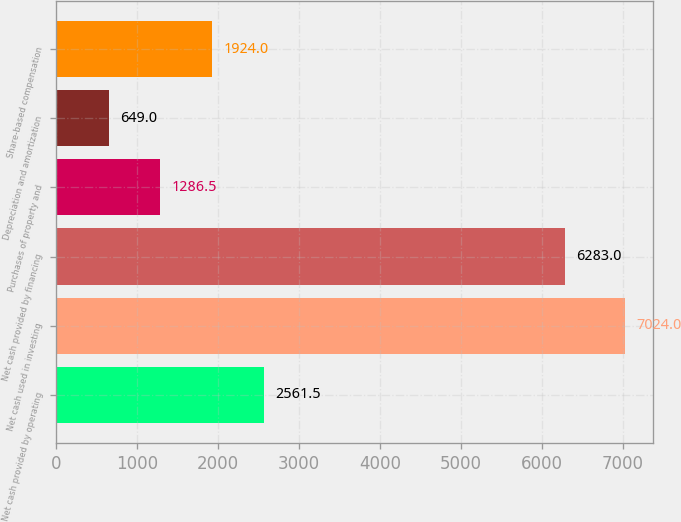<chart> <loc_0><loc_0><loc_500><loc_500><bar_chart><fcel>Net cash provided by operating<fcel>Net cash used in investing<fcel>Net cash provided by financing<fcel>Purchases of property and<fcel>Depreciation and amortization<fcel>Share-based compensation<nl><fcel>2561.5<fcel>7024<fcel>6283<fcel>1286.5<fcel>649<fcel>1924<nl></chart> 